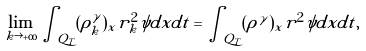Convert formula to latex. <formula><loc_0><loc_0><loc_500><loc_500>\lim _ { k \rightarrow + \infty } \int _ { Q _ { T } } ( \rho _ { k } ^ { \gamma } ) _ { x } r _ { k } ^ { 2 } \psi d x d t = \int _ { Q _ { T } } ( \rho ^ { \gamma } ) _ { x } r ^ { 2 } \psi d x d t ,</formula> 